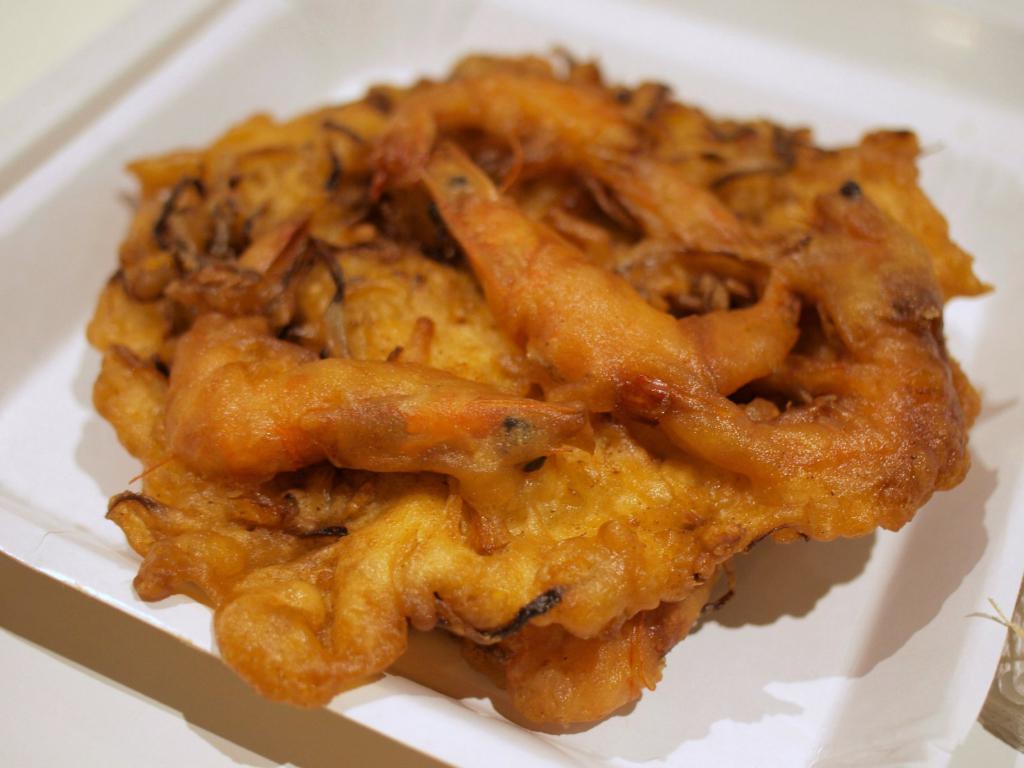Please provide a concise description of this image. In this image we can see the food item on the plate which is on the white color surface. 